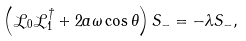<formula> <loc_0><loc_0><loc_500><loc_500>\left ( { \mathcal { L } _ { 0 } \mathcal { L } ^ { \dag } _ { 1 } + 2 a \omega \cos \theta } \right ) S _ { - } = - \lambda S _ { - } ,</formula> 